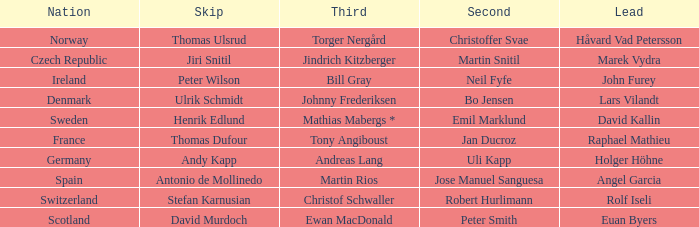Which Skip has a Third of tony angiboust? Thomas Dufour. 